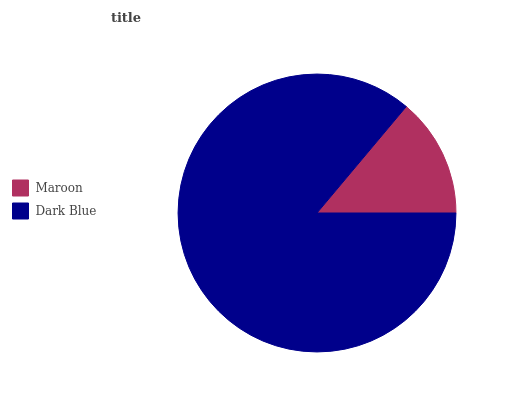Is Maroon the minimum?
Answer yes or no. Yes. Is Dark Blue the maximum?
Answer yes or no. Yes. Is Dark Blue the minimum?
Answer yes or no. No. Is Dark Blue greater than Maroon?
Answer yes or no. Yes. Is Maroon less than Dark Blue?
Answer yes or no. Yes. Is Maroon greater than Dark Blue?
Answer yes or no. No. Is Dark Blue less than Maroon?
Answer yes or no. No. Is Dark Blue the high median?
Answer yes or no. Yes. Is Maroon the low median?
Answer yes or no. Yes. Is Maroon the high median?
Answer yes or no. No. Is Dark Blue the low median?
Answer yes or no. No. 